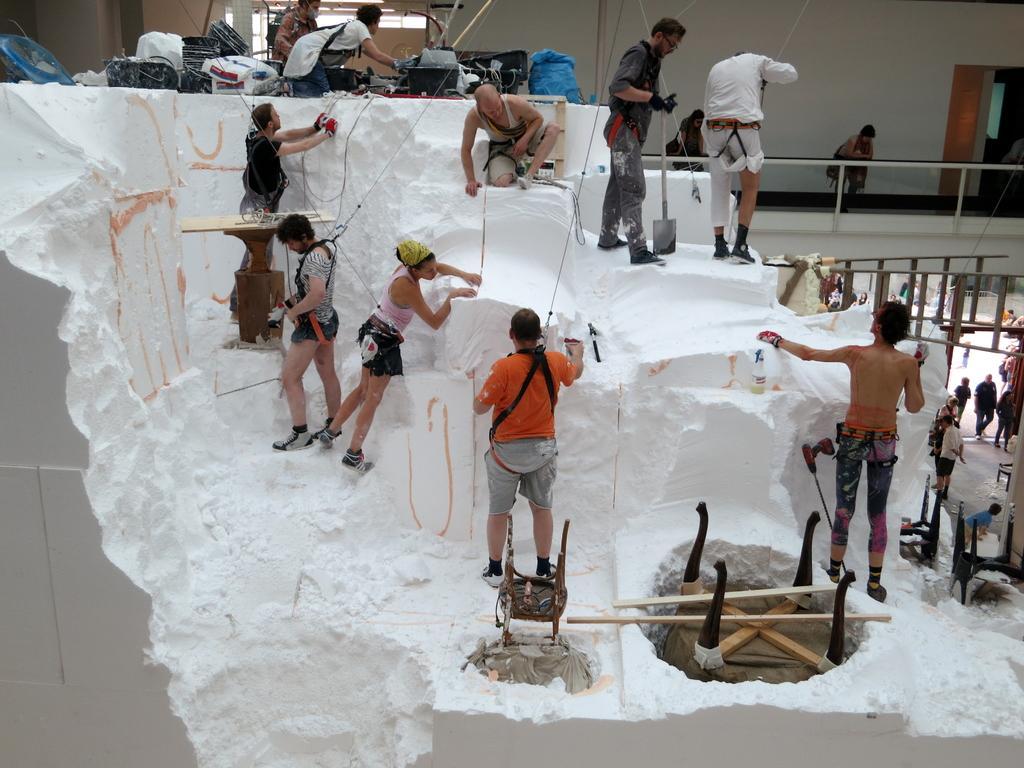Can you describe this image briefly? In this picture we can see a group of people where all are doing their activities. The person holding the rope and standing and here the person is holding some excavation material and this person is sitting and this person is watching to the wall and here are some tables, wooden planks and here the persons are walking and this woman at the balcony and watching to all of them and here it is a wall, door. 